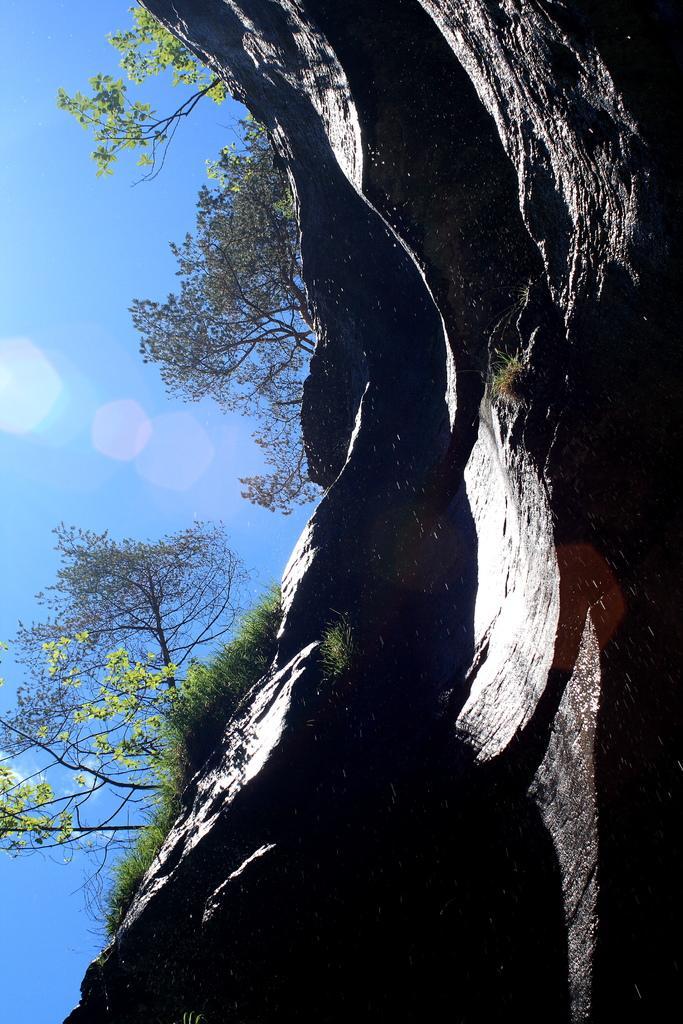Please provide a concise description of this image. Here we can see a mountain, grass, and trees. In the background there is sky. 